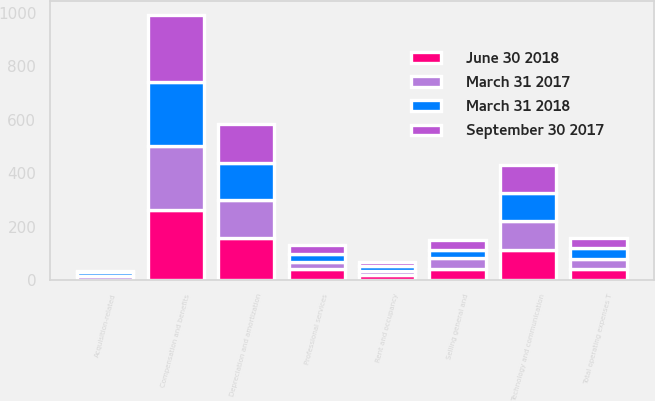<chart> <loc_0><loc_0><loc_500><loc_500><stacked_bar_chart><ecel><fcel>Compensation and benefits<fcel>Professional services<fcel>Acquisition-related<fcel>Technology and communication<fcel>Rent and occupancy<fcel>Selling general and<fcel>Depreciation and amortization<fcel>Total operating expenses T<nl><fcel>June 30 2018<fcel>262<fcel>40<fcel>1<fcel>112<fcel>18<fcel>42<fcel>157<fcel>39.5<nl><fcel>September 30 2017<fcel>251<fcel>32<fcel>6<fcel>107<fcel>17<fcel>37<fcel>148<fcel>39.5<nl><fcel>March 31 2017<fcel>241<fcel>29<fcel>15<fcel>108<fcel>16<fcel>39<fcel>143<fcel>39.5<nl><fcel>March 31 2018<fcel>240<fcel>30<fcel>12<fcel>105<fcel>17<fcel>33<fcel>138<fcel>39.5<nl></chart> 